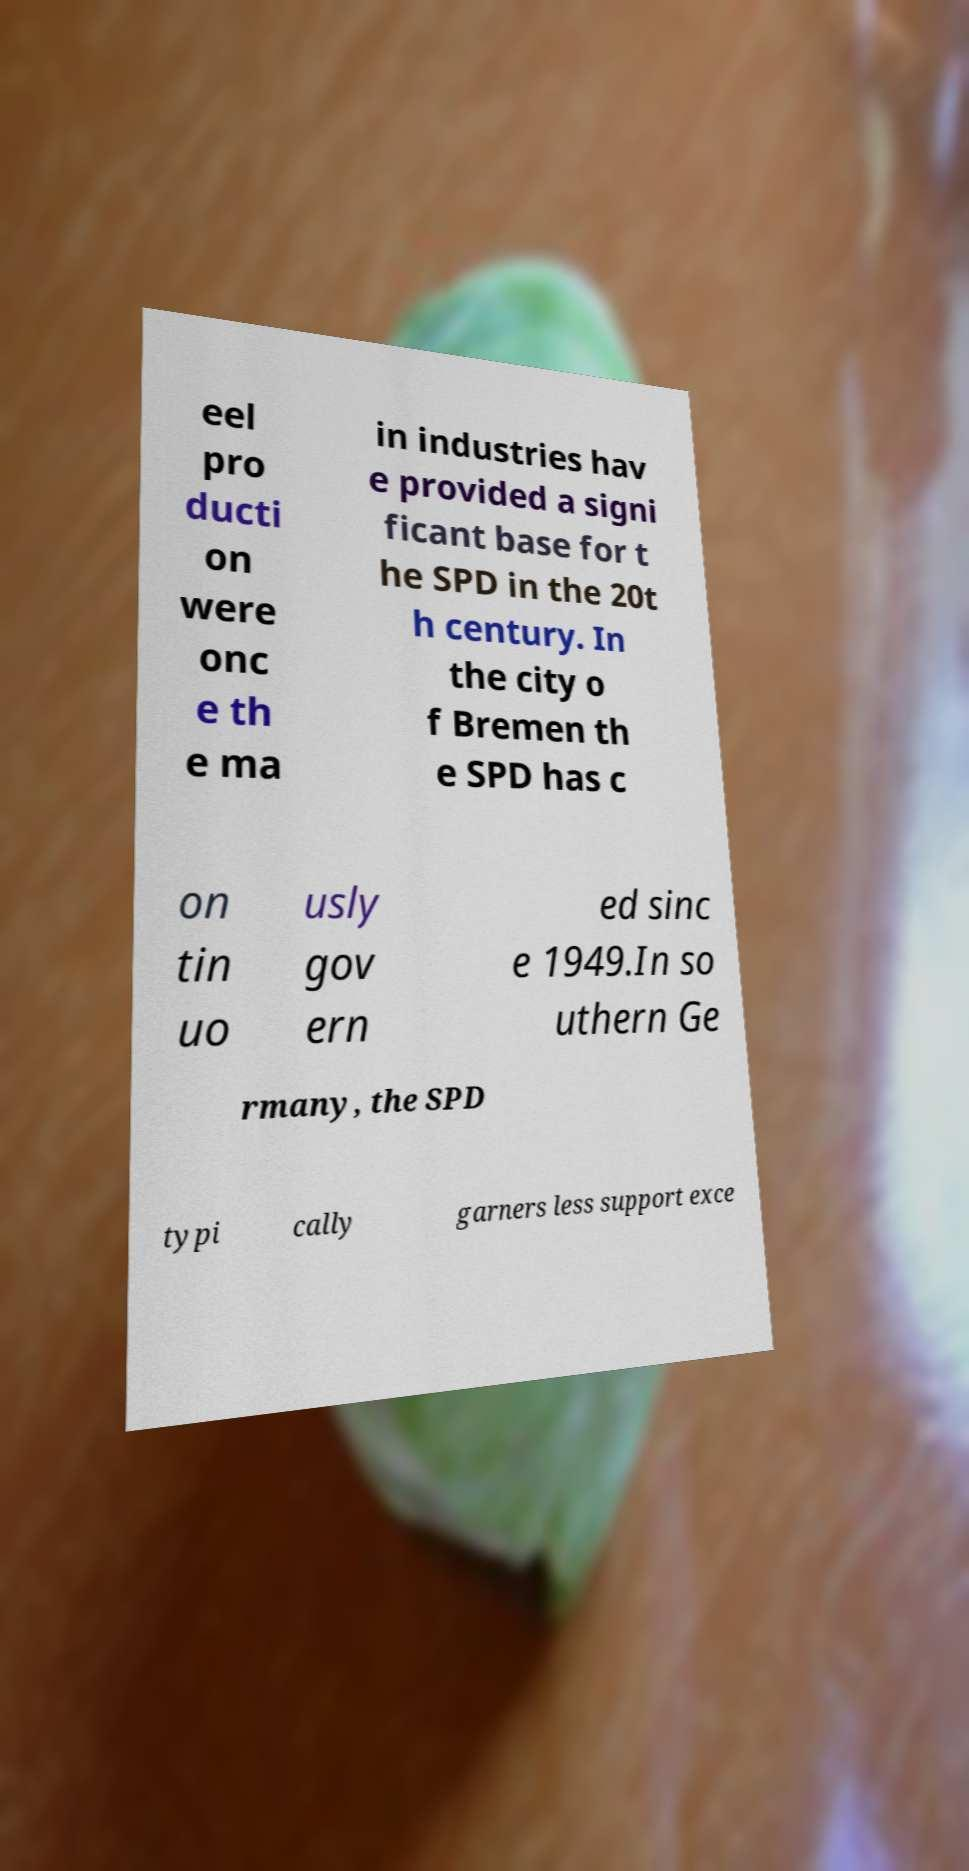I need the written content from this picture converted into text. Can you do that? eel pro ducti on were onc e th e ma in industries hav e provided a signi ficant base for t he SPD in the 20t h century. In the city o f Bremen th e SPD has c on tin uo usly gov ern ed sinc e 1949.In so uthern Ge rmany, the SPD typi cally garners less support exce 